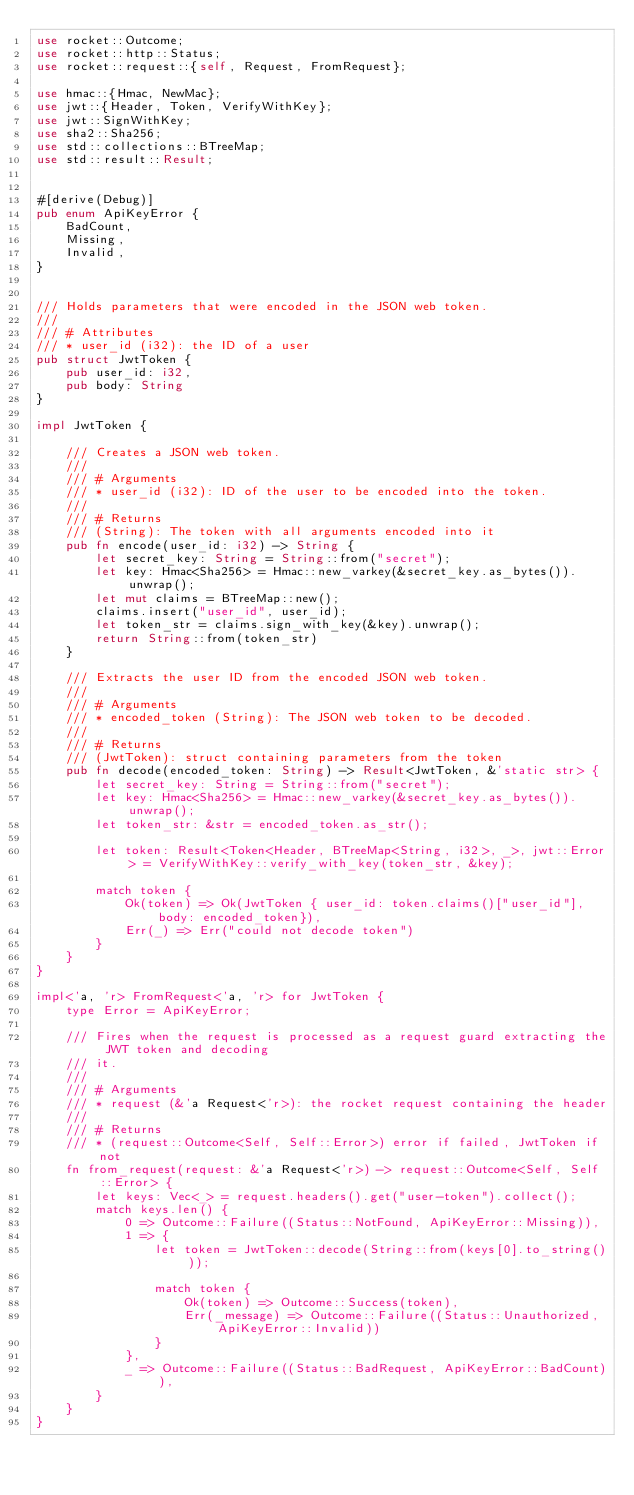<code> <loc_0><loc_0><loc_500><loc_500><_Rust_>use rocket::Outcome;
use rocket::http::Status;
use rocket::request::{self, Request, FromRequest};

use hmac::{Hmac, NewMac};
use jwt::{Header, Token, VerifyWithKey};
use jwt::SignWithKey;
use sha2::Sha256;
use std::collections::BTreeMap;
use std::result::Result;


#[derive(Debug)]
pub enum ApiKeyError {
    BadCount,
    Missing,
    Invalid,
}


/// Holds parameters that were encoded in the JSON web token.
///
/// # Attributes
/// * user_id (i32): the ID of a user
pub struct JwtToken {
    pub user_id: i32,
    pub body: String
}

impl JwtToken {

    /// Creates a JSON web token.
    ///
    /// # Arguments
    /// * user_id (i32): ID of the user to be encoded into the token.
    ///
    /// # Returns
    /// (String): The token with all arguments encoded into it
    pub fn encode(user_id: i32) -> String {
        let secret_key: String = String::from("secret");
        let key: Hmac<Sha256> = Hmac::new_varkey(&secret_key.as_bytes()).unwrap();
        let mut claims = BTreeMap::new();
        claims.insert("user_id", user_id);
        let token_str = claims.sign_with_key(&key).unwrap();
        return String::from(token_str)
    }

    /// Extracts the user ID from the encoded JSON web token.
    ///
    /// # Arguments
    /// * encoded_token (String): The JSON web token to be decoded.
    ///
    /// # Returns
    /// (JwtToken): struct containing parameters from the token
    pub fn decode(encoded_token: String) -> Result<JwtToken, &'static str> {
        let secret_key: String = String::from("secret");
        let key: Hmac<Sha256> = Hmac::new_varkey(&secret_key.as_bytes()).unwrap();
        let token_str: &str = encoded_token.as_str();

        let token: Result<Token<Header, BTreeMap<String, i32>, _>, jwt::Error> = VerifyWithKey::verify_with_key(token_str, &key);

        match token {
            Ok(token) => Ok(JwtToken { user_id: token.claims()["user_id"], body: encoded_token}),
            Err(_) => Err("could not decode token")
        }
    }
}

impl<'a, 'r> FromRequest<'a, 'r> for JwtToken {
    type Error = ApiKeyError;

    /// Fires when the request is processed as a request guard extracting the JWT token and decoding
    /// it.
    ///
    /// # Arguments
    /// * request (&'a Request<'r>): the rocket request containing the header
    ///
    /// # Returns
    /// * (request::Outcome<Self, Self::Error>) error if failed, JwtToken if not
    fn from_request(request: &'a Request<'r>) -> request::Outcome<Self, Self::Error> {
        let keys: Vec<_> = request.headers().get("user-token").collect();
        match keys.len() {
            0 => Outcome::Failure((Status::NotFound, ApiKeyError::Missing)),
            1 => {
                let token = JwtToken::decode(String::from(keys[0].to_string()));

                match token {
                    Ok(token) => Outcome::Success(token),
                    Err(_message) => Outcome::Failure((Status::Unauthorized, ApiKeyError::Invalid))
                }
            },
            _ => Outcome::Failure((Status::BadRequest, ApiKeyError::BadCount)),
        }
    }
}</code> 